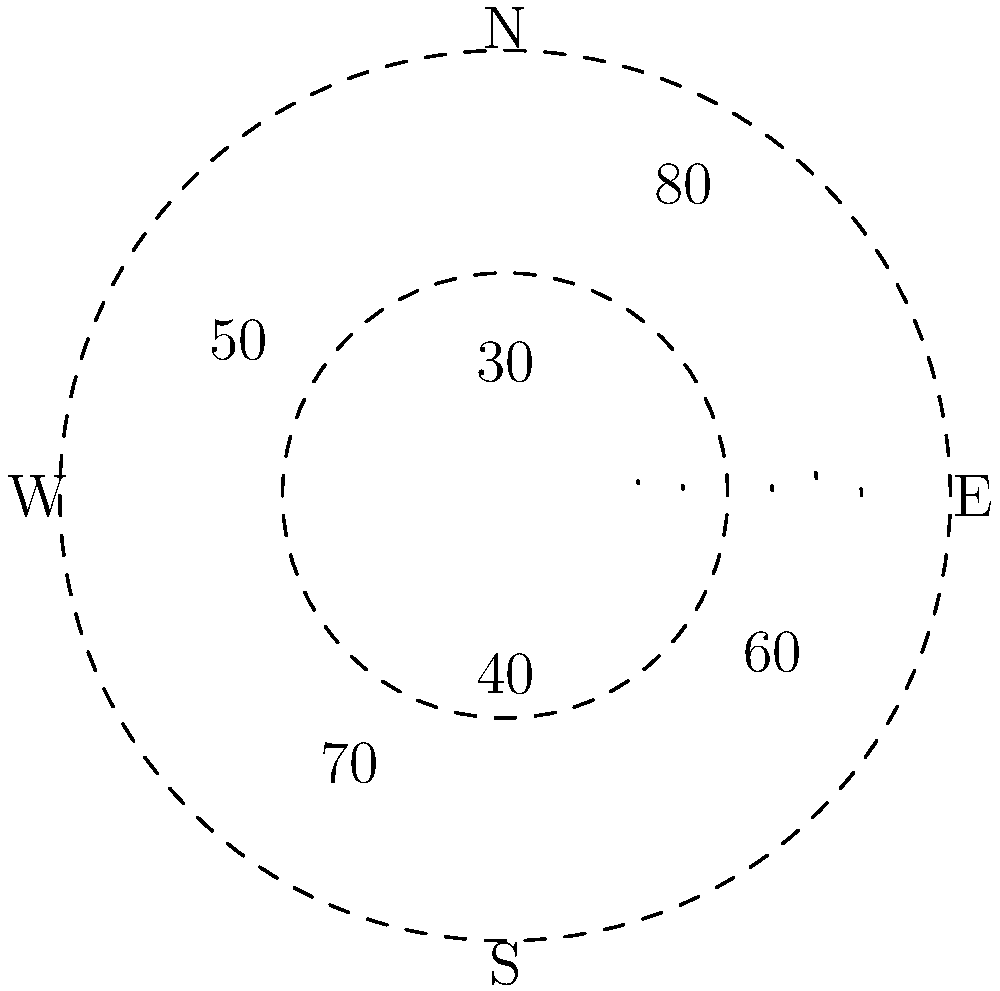As a seasoned politician planning your next campaign strategy, you're presented with a polar area chart showing the geographical distribution of your party membership across six regions. The chart is divided into six equal sectors, with the area of each sector proportional to the number of party members in that region. If the largest sector represents 80,000 members, approximately how many total party members are there across all six regions? To solve this problem, we need to follow these steps:

1. Identify the values for each sector:
   North: 80
   Northeast: 60
   Southeast: 40
   South: 70
   Southwest: 50
   Northwest: 30

2. Calculate the sum of all sector values:
   $80 + 60 + 40 + 70 + 50 + 30 = 330$

3. Set up a proportion to find the total number of members:
   Let x be the total number of members.
   $\frac{80}{330} = \frac{80,000}{x}$

4. Solve for x:
   $x = \frac{330 \times 80,000}{80} = 330,000$

Therefore, the total number of party members across all six regions is approximately 330,000.
Answer: 330,000 members 